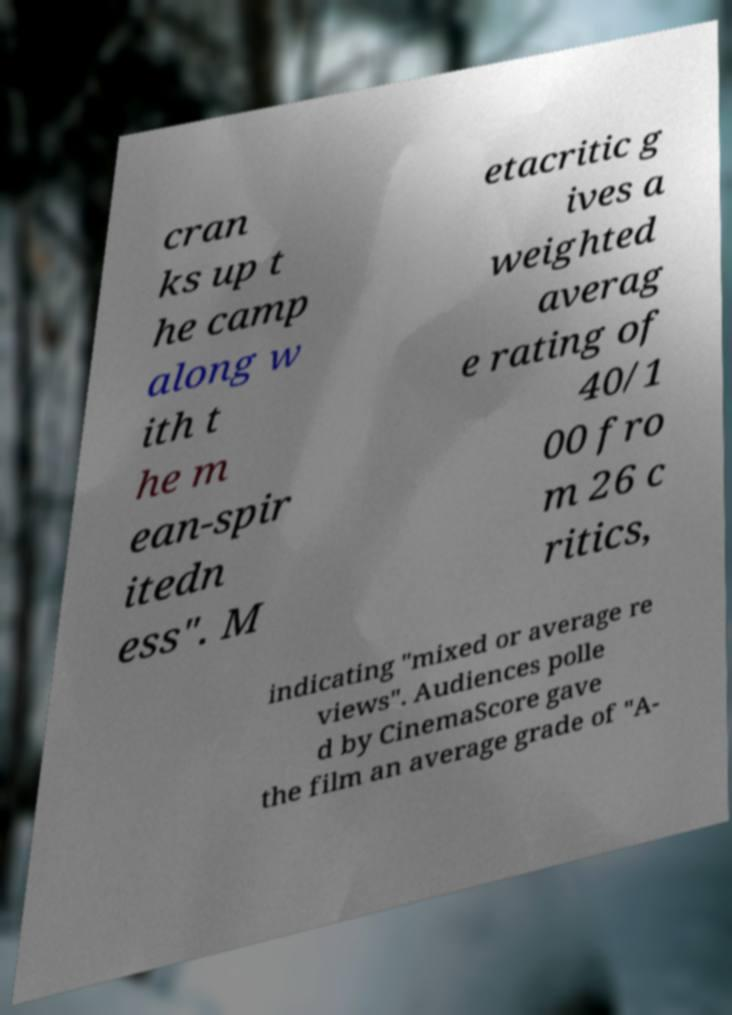Could you assist in decoding the text presented in this image and type it out clearly? cran ks up t he camp along w ith t he m ean-spir itedn ess". M etacritic g ives a weighted averag e rating of 40/1 00 fro m 26 c ritics, indicating "mixed or average re views". Audiences polle d by CinemaScore gave the film an average grade of "A- 